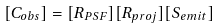<formula> <loc_0><loc_0><loc_500><loc_500>[ C _ { o b s } ] = [ R _ { P S F } ] [ R _ { p r o j } ] [ S _ { e m i t } ]</formula> 